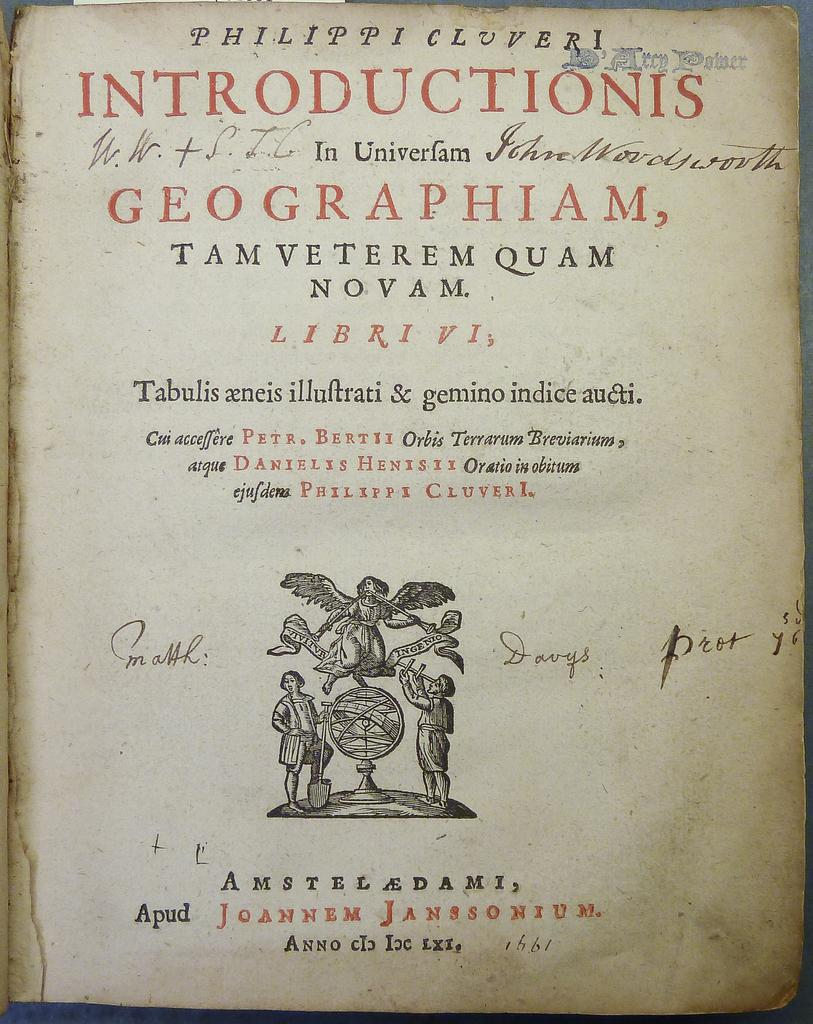What is the main subject of the image? The main subject of the image is a cover page. What can be found on the cover page? There are texts and images on the cover page. What type of lead is used to write the texts on the cover page? There is no indication of the writing instrument used on the cover page, and therefore no specific type of lead can be determined. 